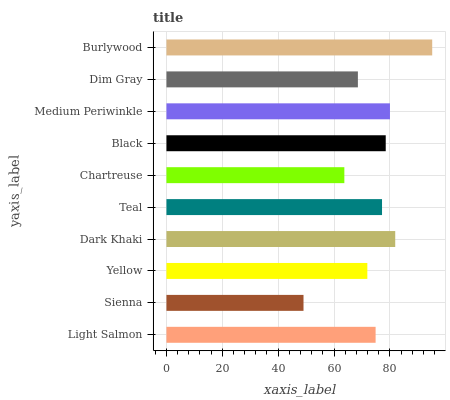Is Sienna the minimum?
Answer yes or no. Yes. Is Burlywood the maximum?
Answer yes or no. Yes. Is Yellow the minimum?
Answer yes or no. No. Is Yellow the maximum?
Answer yes or no. No. Is Yellow greater than Sienna?
Answer yes or no. Yes. Is Sienna less than Yellow?
Answer yes or no. Yes. Is Sienna greater than Yellow?
Answer yes or no. No. Is Yellow less than Sienna?
Answer yes or no. No. Is Teal the high median?
Answer yes or no. Yes. Is Light Salmon the low median?
Answer yes or no. Yes. Is Sienna the high median?
Answer yes or no. No. Is Chartreuse the low median?
Answer yes or no. No. 